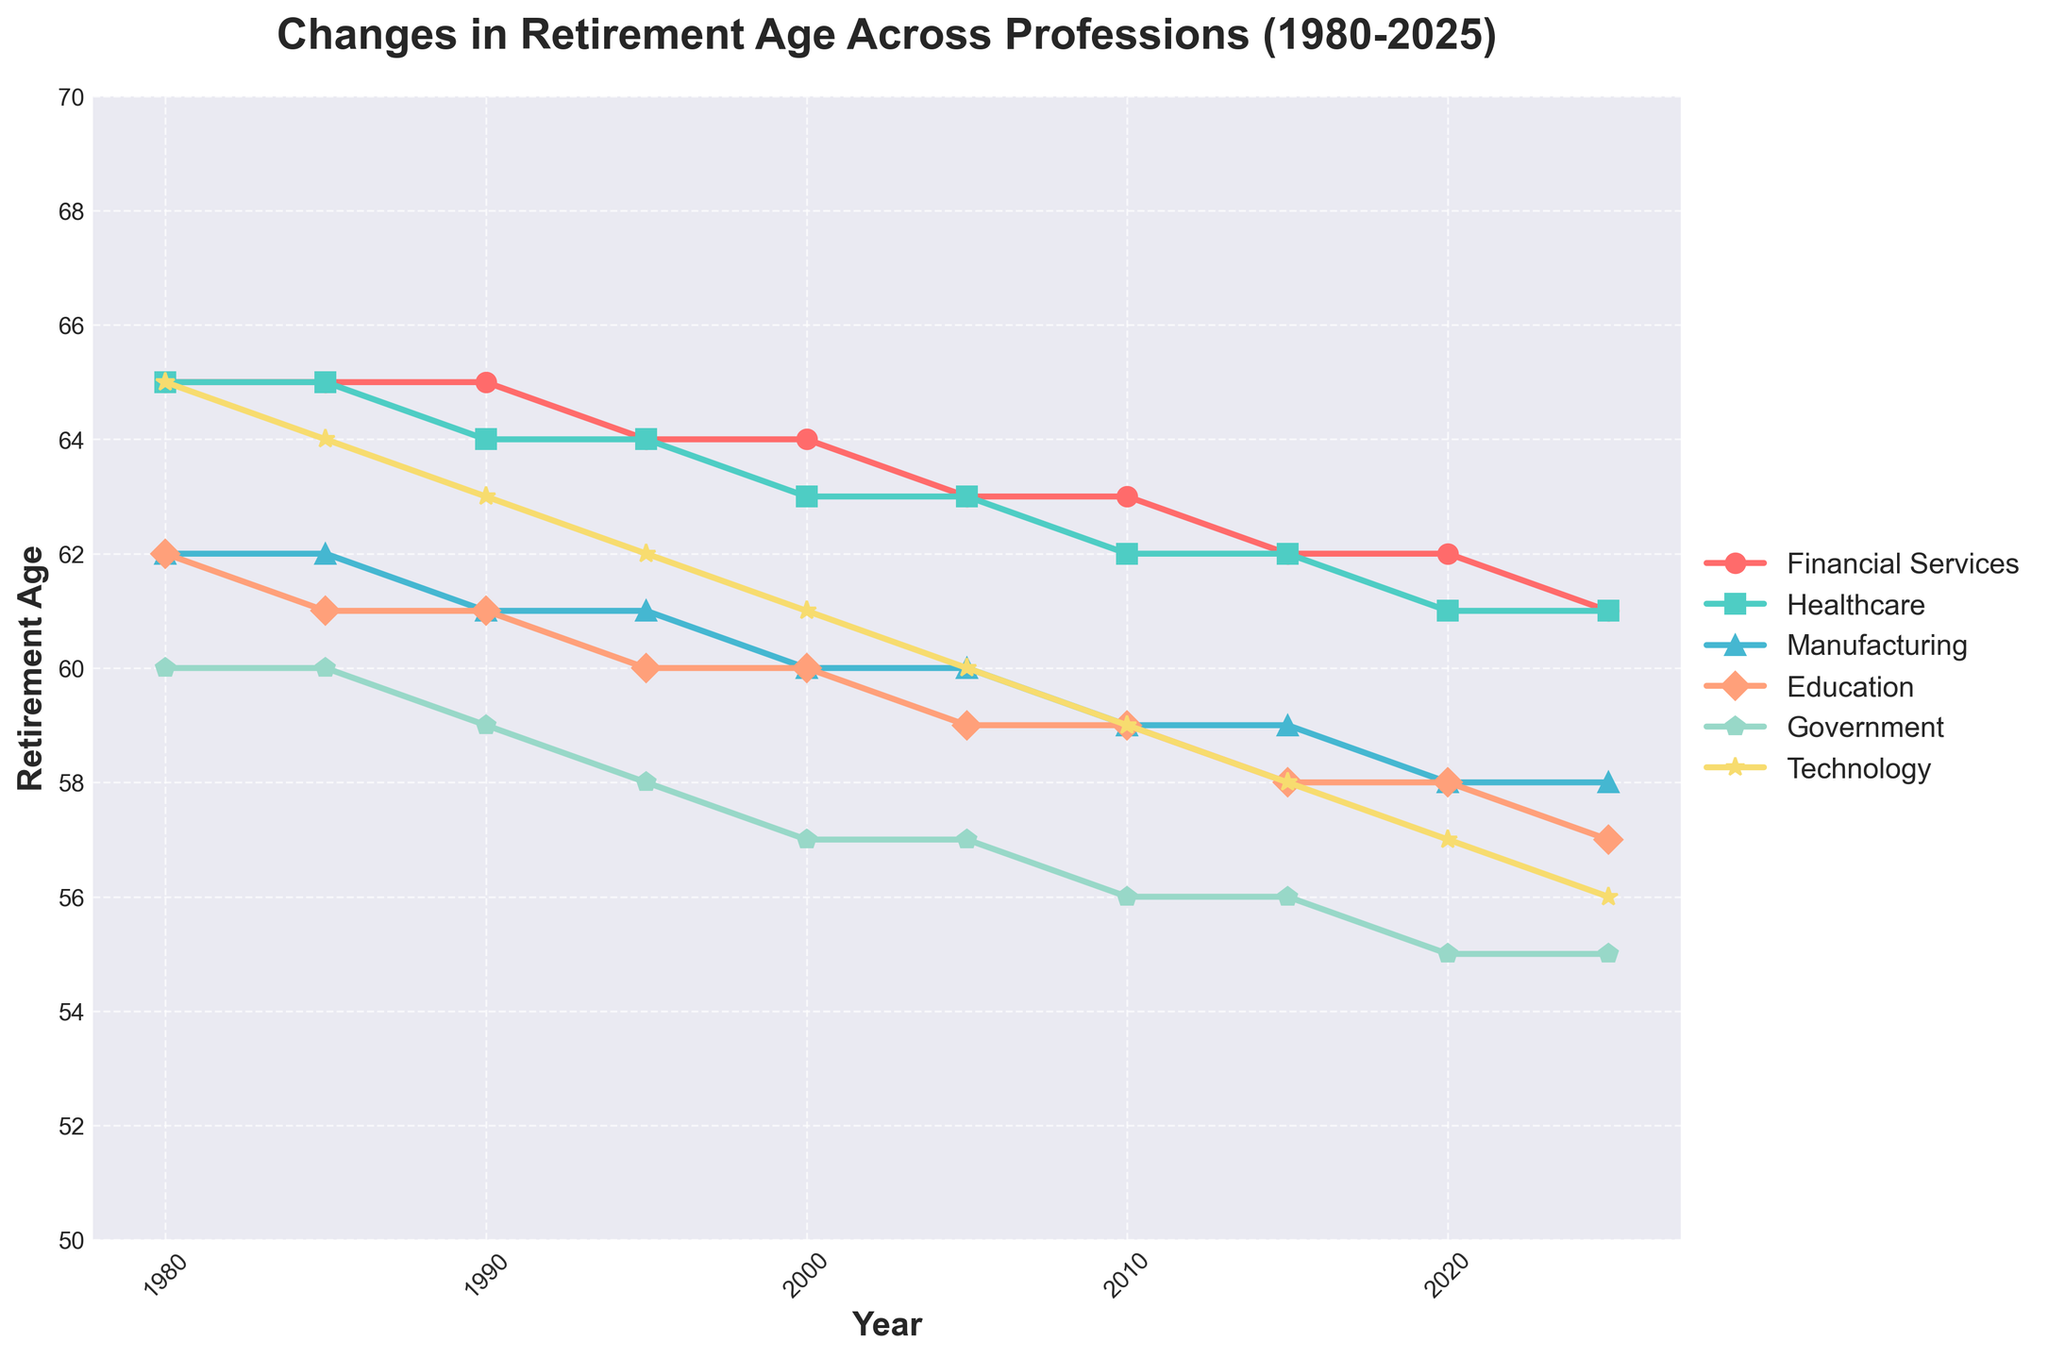What is the trend in retirement age for the Financial Services sector from 1980 to 2025? Look at the red line representing Financial Services. It starts at 65 in 1980 and decreases slightly over the years, reaching around 61 in 2025.
Answer: Decreasing Which sector had the highest retirement age in 2005? Refer to the 2005 data point across all sectors. The Financial Services sector had a retirement age of 63. Other sectors have either 63 or lower retirement ages.
Answer: Financial Services Between 1980 and 2025, by how many years did the retirement age in the Healthcare sector decrease? In 1980, the Healthcare retirement age was 65. By 2025, it decreased to 61. Subtract 61 from 65 to get the total decrease.
Answer: 4 years Which sector had the most significant drop in retirement age from 1980 to 2025? Compare the initial and final values for each sector: Financial Services decreases by 4, Healthcare by 4, Manufacturing by 4, Education by 5, Government by 5, and Technology by 9 years.
Answer: Technology What is the average retirement age for the Manufacturing sector over the given years? Sum the given retirement ages for Manufacturing (62, 62, 61, 61, 60, 60, 59, 59, 58, 58) and divide by the number of data points (10). (62 + 62 + 61 + 61 + 60 + 60 + 59 + 59 + 58 + 58)/10 = 60.
Answer: 60 Compare the retirement ages of the Education and Government sectors in 2020. Which is higher? Look at the data points for 2020: Education is 58, and Government is 55. Education has a higher retirement age.
Answer: Education How did the retirement age in the Technology sector change between 1980 and 2000? Compare values in 1980 (65) and 2000 (61). The change is 65 - 61 = 4 years decrease.
Answer: Decreased by 4 years Which sector had a constant retirement age from 1980 to 2025? Review each line to see any sectors without change. Only the Healthcare sector (constant decrease) shows similar retirement ages without drastic fluctuations.
Answer: None What is the median retirement age of the Education sector from 1980 to 2025? List the retirement ages in ascending order (58, 58, 59, 59, 60, 60, 61, 61, 62, 62). The median value is the average of the middle values (60+60)/2.
Answer: 60 In what year did the Government sector reach a retirement age below 60? Observe the data points: Government retirement age falls below 60 in 1995 (59) and remains below 60 in subsequent years.
Answer: 1995 